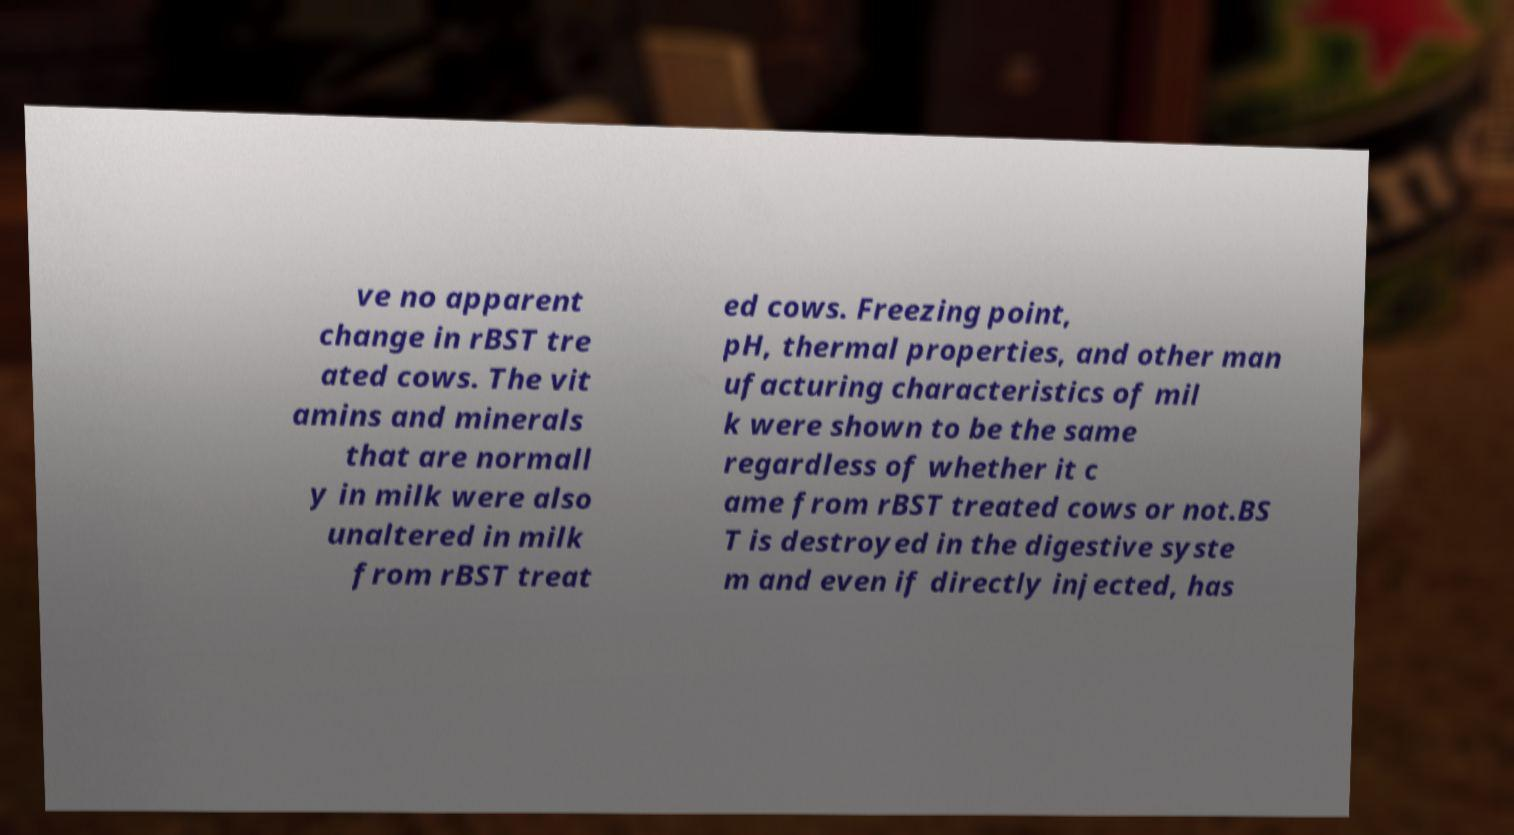There's text embedded in this image that I need extracted. Can you transcribe it verbatim? ve no apparent change in rBST tre ated cows. The vit amins and minerals that are normall y in milk were also unaltered in milk from rBST treat ed cows. Freezing point, pH, thermal properties, and other man ufacturing characteristics of mil k were shown to be the same regardless of whether it c ame from rBST treated cows or not.BS T is destroyed in the digestive syste m and even if directly injected, has 